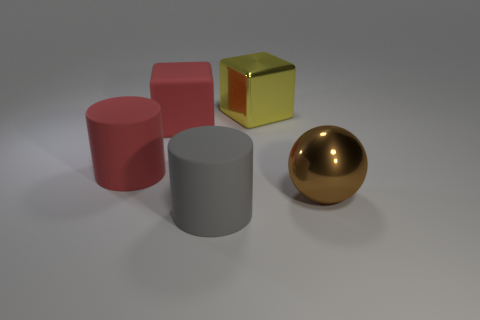Add 2 shiny objects. How many objects exist? 7 Subtract all cylinders. How many objects are left? 3 Add 1 green metal cubes. How many green metal cubes exist? 1 Subtract 0 yellow spheres. How many objects are left? 5 Subtract all brown shiny things. Subtract all red rubber spheres. How many objects are left? 4 Add 4 brown metallic objects. How many brown metallic objects are left? 5 